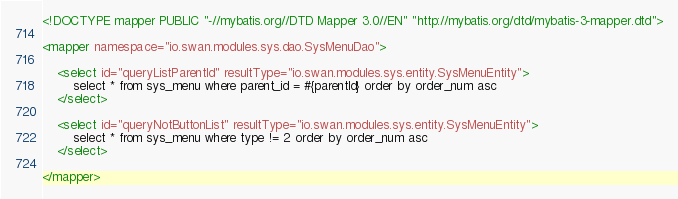<code> <loc_0><loc_0><loc_500><loc_500><_XML_><!DOCTYPE mapper PUBLIC "-//mybatis.org//DTD Mapper 3.0//EN" "http://mybatis.org/dtd/mybatis-3-mapper.dtd">

<mapper namespace="io.swan.modules.sys.dao.SysMenuDao">

	<select id="queryListParentId" resultType="io.swan.modules.sys.entity.SysMenuEntity">
		select * from sys_menu where parent_id = #{parentId} order by order_num asc 
	</select>
	
	<select id="queryNotButtonList" resultType="io.swan.modules.sys.entity.SysMenuEntity">
		select * from sys_menu where type != 2 order by order_num asc 
	</select>
	
</mapper></code> 